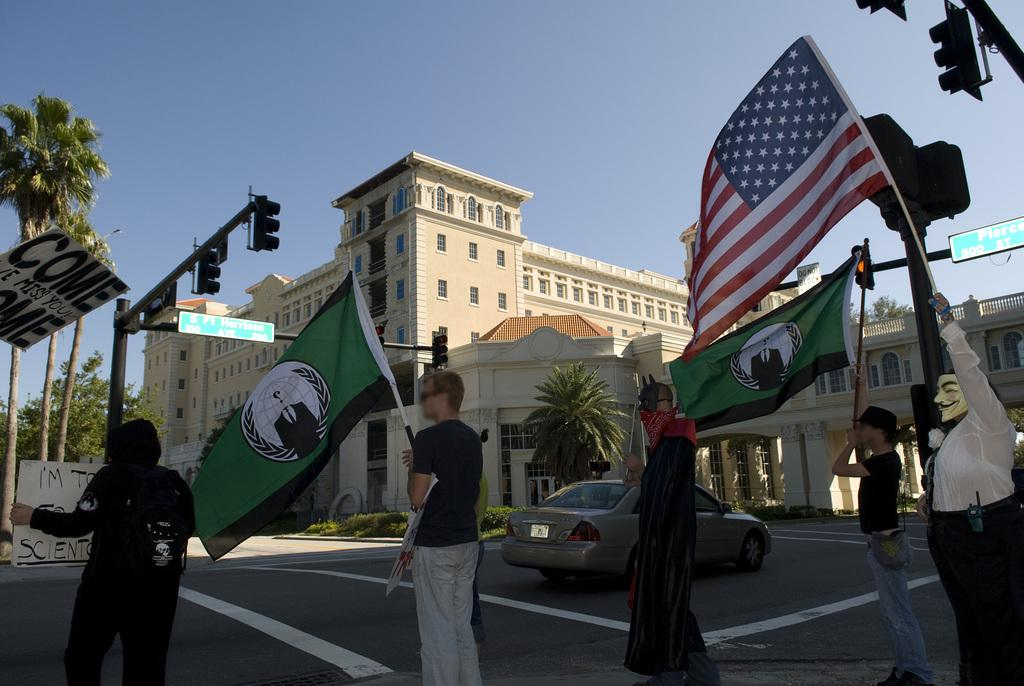Who or what can be seen in the image? There are people in the image. What are the people doing? The people are walking. What are the people holding in the image? The people are holding placards and flags. What else can be seen in the image? There is a building and a car parked on the road in the image. What type of screw can be seen on the building in the image? There is no screw visible on the building in the image. What thrilling activity are the people participating in while holding the placards and flags? The image does not provide information about any thrilling activities; the people are simply walking while holding placards and flags. 